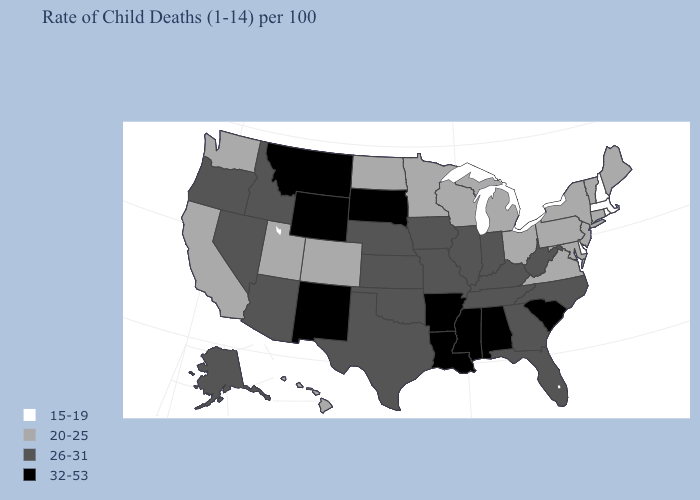Name the states that have a value in the range 20-25?
Write a very short answer. California, Colorado, Connecticut, Hawaii, Maine, Maryland, Michigan, Minnesota, New Jersey, New York, North Dakota, Ohio, Pennsylvania, Utah, Vermont, Virginia, Washington, Wisconsin. Does Oklahoma have the highest value in the USA?
Answer briefly. No. Does the map have missing data?
Concise answer only. No. Is the legend a continuous bar?
Quick response, please. No. Name the states that have a value in the range 32-53?
Be succinct. Alabama, Arkansas, Louisiana, Mississippi, Montana, New Mexico, South Carolina, South Dakota, Wyoming. What is the value of Texas?
Write a very short answer. 26-31. What is the value of Rhode Island?
Answer briefly. 15-19. Among the states that border Oregon , does Washington have the lowest value?
Concise answer only. Yes. Does Connecticut have the highest value in the Northeast?
Short answer required. Yes. Name the states that have a value in the range 32-53?
Concise answer only. Alabama, Arkansas, Louisiana, Mississippi, Montana, New Mexico, South Carolina, South Dakota, Wyoming. Name the states that have a value in the range 26-31?
Write a very short answer. Alaska, Arizona, Florida, Georgia, Idaho, Illinois, Indiana, Iowa, Kansas, Kentucky, Missouri, Nebraska, Nevada, North Carolina, Oklahoma, Oregon, Tennessee, Texas, West Virginia. Which states have the highest value in the USA?
Give a very brief answer. Alabama, Arkansas, Louisiana, Mississippi, Montana, New Mexico, South Carolina, South Dakota, Wyoming. Is the legend a continuous bar?
Concise answer only. No. Name the states that have a value in the range 20-25?
Give a very brief answer. California, Colorado, Connecticut, Hawaii, Maine, Maryland, Michigan, Minnesota, New Jersey, New York, North Dakota, Ohio, Pennsylvania, Utah, Vermont, Virginia, Washington, Wisconsin. Does Oregon have a higher value than Michigan?
Give a very brief answer. Yes. 